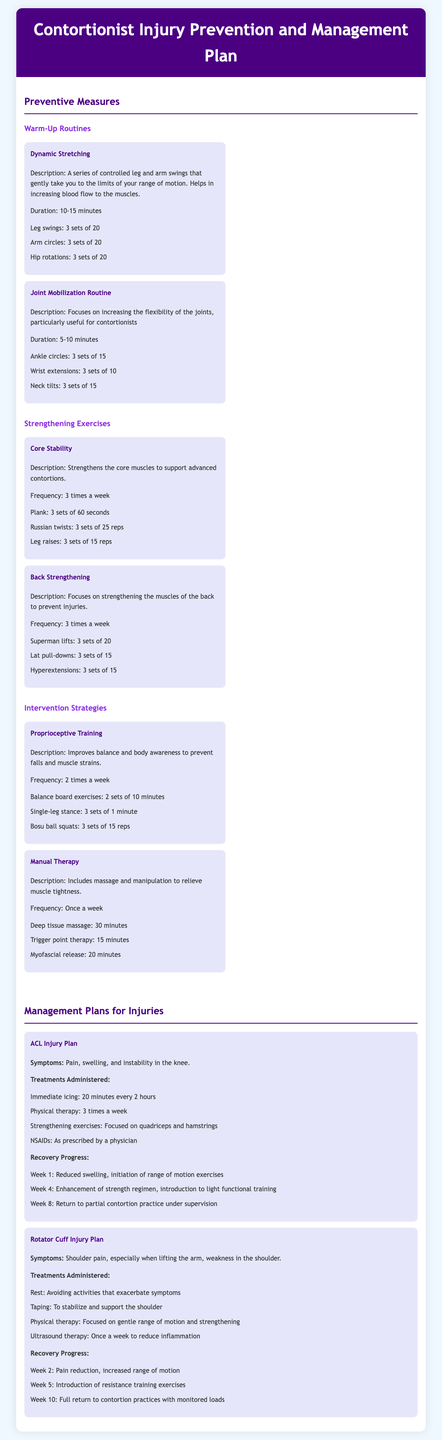What is the duration of the Dynamic Stretching routine? The duration of the Dynamic Stretching routine is listed in the document.
Answer: 10-15 minutes How many sets of Leg swings are recommended? The number of sets for Leg swings is detailed under the Dynamic Stretching routine.
Answer: 3 sets of 20 What is the frequency of Core Stability exercises? The frequency of Core Stability exercises is specified in the Strengthening Exercises section.
Answer: 3 times a week What is the purpose of Proprioceptive Training? The purpose of Proprioceptive Training is found under Intervention Strategies.
Answer: Improves balance and body awareness What are the initial symptoms of an ACL Injury? The initial symptoms for an ACL Injury are stated in the Management Plans for Injuries section.
Answer: Pain, swelling, and instability in the knee How often is Manual Therapy recommended? The frequency of Manual Therapy is mentioned in the Intervention Strategies section.
Answer: Once a week What type of therapy is used for a Rotator Cuff Injury? The types of treatments used for a Rotator Cuff Injury are detailed under its Injury Plan.
Answer: Rest, taping, physical therapy, ultrasound therapy During which week is partial contortion practice introduced for ACL injury recovery? The timeline for recovery progress regarding ACL injuries includes when partial practice is introduced.
Answer: Week 8 What type of exercise involves Bosu ball squats? This type of exercise is categorized under Proprioceptive Training in the document.
Answer: Proprioceptive Training 